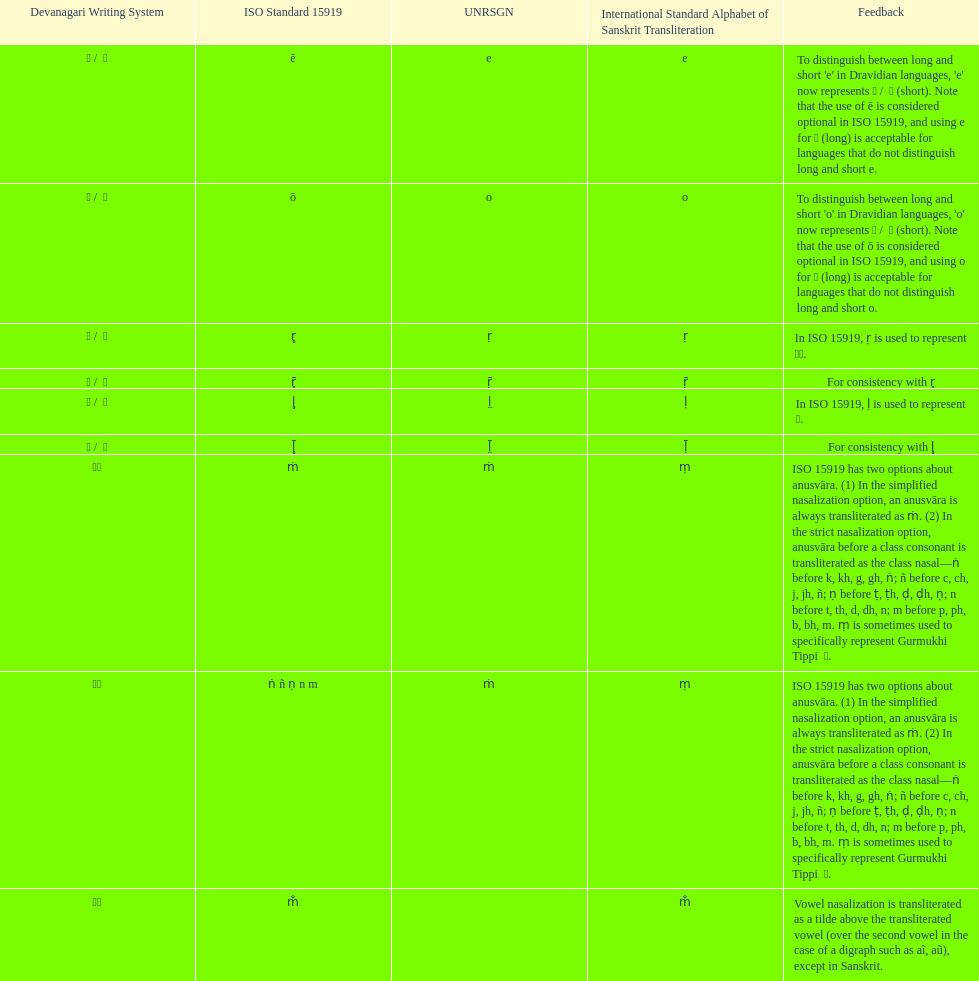How many total options are there about anusvara? 2. Could you parse the entire table as a dict? {'header': ['Devanagari Writing System', 'ISO Standard 15919', 'UNRSGN', 'International Standard Alphabet of Sanskrit Transliteration', 'Feedback'], 'rows': [['ए / \xa0े', 'ē', 'e', 'e', "To distinguish between long and short 'e' in Dravidian languages, 'e' now represents ऎ / \xa0ॆ (short). Note that the use of ē is considered optional in ISO 15919, and using e for ए (long) is acceptable for languages that do not distinguish long and short e."], ['ओ / \xa0ो', 'ō', 'o', 'o', "To distinguish between long and short 'o' in Dravidian languages, 'o' now represents ऒ / \xa0ॊ (short). Note that the use of ō is considered optional in ISO 15919, and using o for ओ (long) is acceptable for languages that do not distinguish long and short o."], ['ऋ / \xa0ृ', 'r̥', 'ṛ', 'ṛ', 'In ISO 15919, ṛ is used to represent ड़.'], ['ॠ / \xa0ॄ', 'r̥̄', 'ṝ', 'ṝ', 'For consistency with r̥'], ['ऌ / \xa0ॢ', 'l̥', 'l̤', 'ḷ', 'In ISO 15919, ḷ is used to represent ळ.'], ['ॡ / \xa0ॣ', 'l̥̄', 'l̤̄', 'ḹ', 'For consistency with l̥'], ['◌ं', 'ṁ', 'ṁ', 'ṃ', 'ISO 15919 has two options about anusvāra. (1) In the simplified nasalization option, an anusvāra is always transliterated as ṁ. (2) In the strict nasalization option, anusvāra before a class consonant is transliterated as the class nasal—ṅ before k, kh, g, gh, ṅ; ñ before c, ch, j, jh, ñ; ṇ before ṭ, ṭh, ḍ, ḍh, ṇ; n before t, th, d, dh, n; m before p, ph, b, bh, m. ṃ is sometimes used to specifically represent Gurmukhi Tippi \xa0ੰ.'], ['◌ं', 'ṅ ñ ṇ n m', 'ṁ', 'ṃ', 'ISO 15919 has two options about anusvāra. (1) In the simplified nasalization option, an anusvāra is always transliterated as ṁ. (2) In the strict nasalization option, anusvāra before a class consonant is transliterated as the class nasal—ṅ before k, kh, g, gh, ṅ; ñ before c, ch, j, jh, ñ; ṇ before ṭ, ṭh, ḍ, ḍh, ṇ; n before t, th, d, dh, n; m before p, ph, b, bh, m. ṃ is sometimes used to specifically represent Gurmukhi Tippi \xa0ੰ.'], ['◌ँ', 'm̐', '', 'm̐', 'Vowel nasalization is transliterated as a tilde above the transliterated vowel (over the second vowel in the case of a digraph such as aĩ, aũ), except in Sanskrit.']]} 